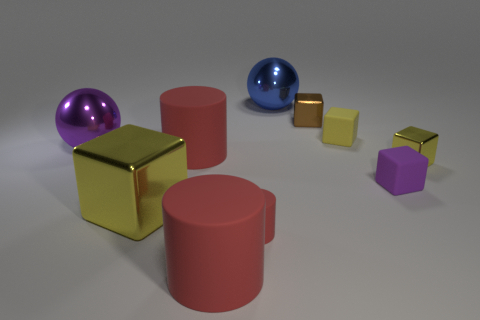What kind of atmosphere or mood does the arrangement of these objects evoke? The arrangement evokes a minimalist and almost surreal atmosphere where the object's colors and reflections contribute to a feeling of calm and order. The spatial distribution and soft lighting lend a serene, almost gallery-like quality to the scene. 